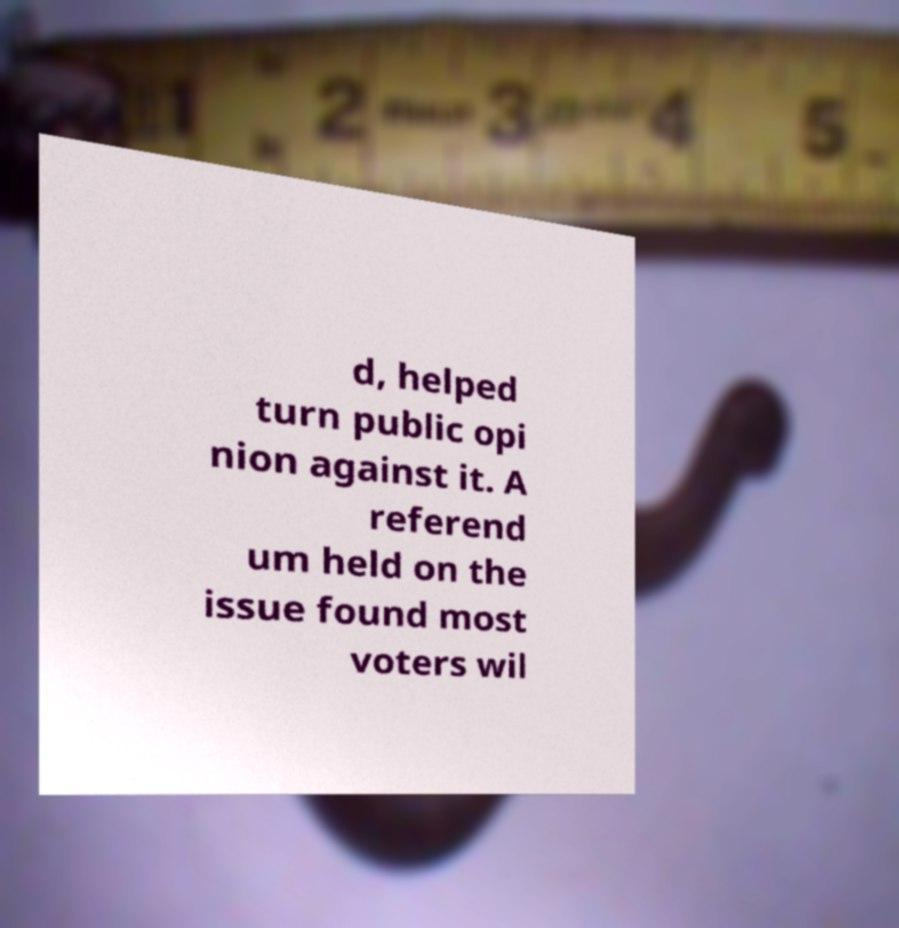Please identify and transcribe the text found in this image. d, helped turn public opi nion against it. A referend um held on the issue found most voters wil 